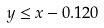<formula> <loc_0><loc_0><loc_500><loc_500>y \leq x - 0 . 1 2 0</formula> 